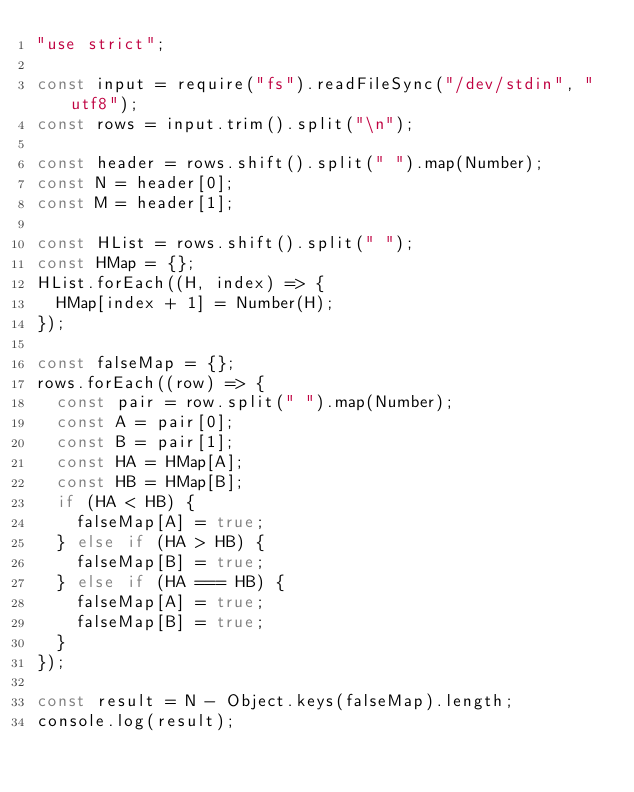<code> <loc_0><loc_0><loc_500><loc_500><_JavaScript_>"use strict";

const input = require("fs").readFileSync("/dev/stdin", "utf8");
const rows = input.trim().split("\n");

const header = rows.shift().split(" ").map(Number);
const N = header[0];
const M = header[1];

const HList = rows.shift().split(" ");
const HMap = {};
HList.forEach((H, index) => {
  HMap[index + 1] = Number(H);
});

const falseMap = {};
rows.forEach((row) => {
  const pair = row.split(" ").map(Number);
  const A = pair[0];
  const B = pair[1];
  const HA = HMap[A];
  const HB = HMap[B];
  if (HA < HB) {
    falseMap[A] = true;
  } else if (HA > HB) {
    falseMap[B] = true;
  } else if (HA === HB) {
    falseMap[A] = true;
    falseMap[B] = true;
  }
});

const result = N - Object.keys(falseMap).length;
console.log(result);
</code> 